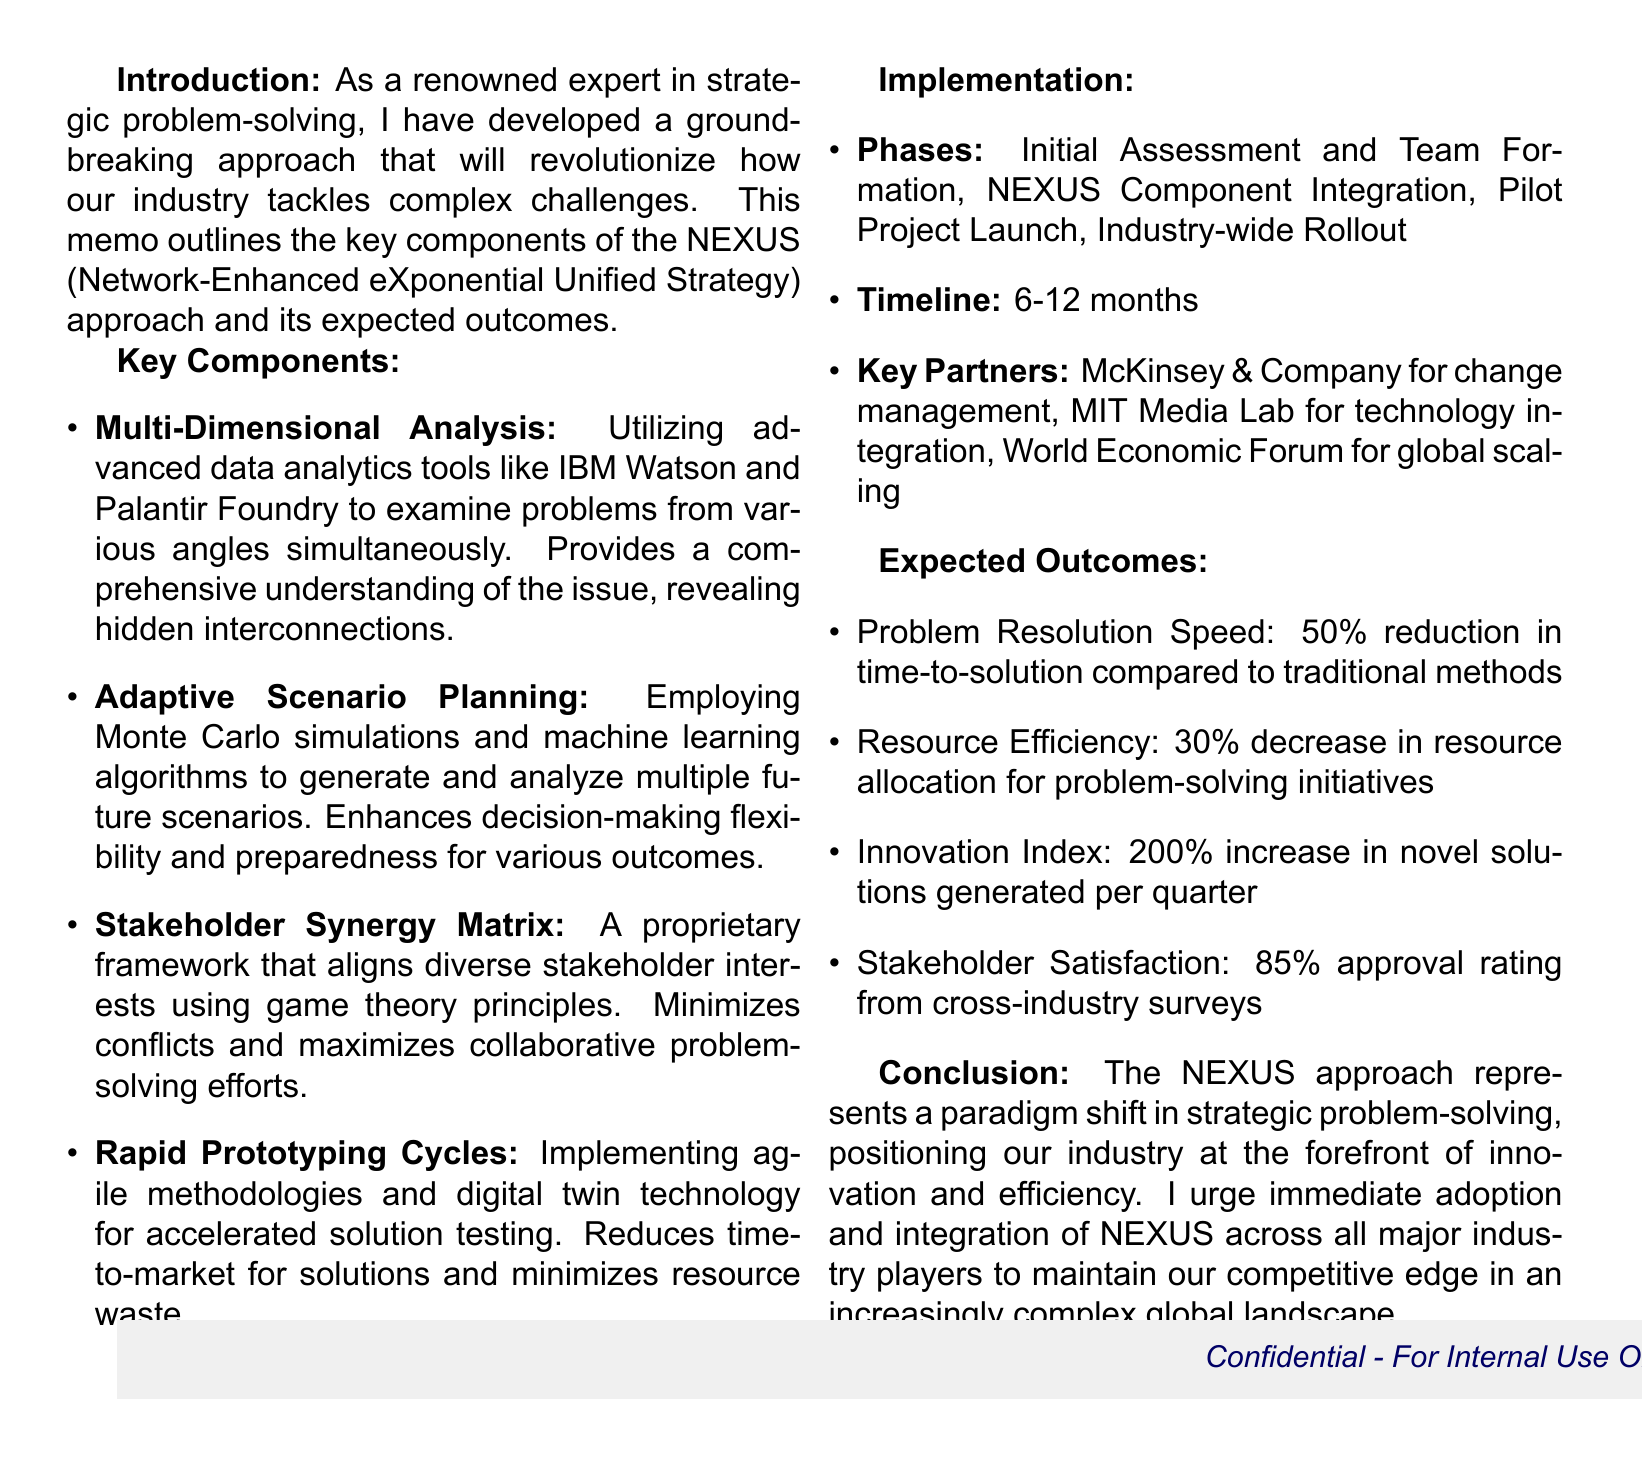What is the title of the memo? The title is stated at the top of the memo, identifying the strategic approach being discussed.
Answer: Revolutionary Problem-Solving Strategy for the Industry: The NEXUS Approach What is the main purpose of the NEXUS approach? The purpose is outlined in the introduction, emphasizing the approach's intention to revolutionize problem-solving.
Answer: To revolutionize how our industry tackles complex challenges How many key components are outlined in the memo? The number of key components is specified in the "Key Components" section.
Answer: Four What is the expected improvement in the problem resolution speed? The expected improvement for problem resolution speed is mentioned under "Expected Outcomes."
Answer: 50% reduction Which company is a key partner for change management? The key partner for change management is listed in the "Key Partners" section.
Answer: McKinsey & Company What does the Stakeholder Synergy Matrix utilize to minimize conflicts? The Stakeholder Synergy Matrix description explains its basis in certain principles.
Answer: Game theory principles What is the estimated timeline for implementing the NEXUS approach? The timeline for implementing NEXUS is provided in the "Implementation" section.
Answer: 6-12 months What is the expected increase in the Innovation Index per quarter? The expected increase in the Innovation Index is noted in the "Expected Outcomes."
Answer: 200% increase 